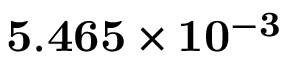Convert formula to latex. <formula><loc_0><loc_0><loc_500><loc_500>5 . 4 6 5 \times 1 0 ^ { - 3 }</formula> 